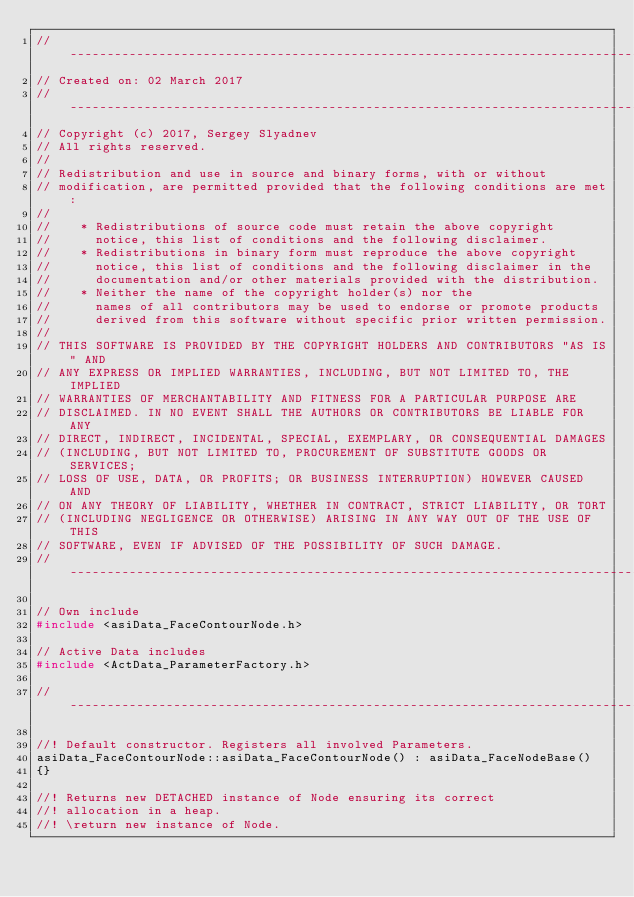Convert code to text. <code><loc_0><loc_0><loc_500><loc_500><_C++_>//-----------------------------------------------------------------------------
// Created on: 02 March 2017
//-----------------------------------------------------------------------------
// Copyright (c) 2017, Sergey Slyadnev
// All rights reserved.
//
// Redistribution and use in source and binary forms, with or without
// modification, are permitted provided that the following conditions are met:
//
//    * Redistributions of source code must retain the above copyright
//      notice, this list of conditions and the following disclaimer.
//    * Redistributions in binary form must reproduce the above copyright
//      notice, this list of conditions and the following disclaimer in the
//      documentation and/or other materials provided with the distribution.
//    * Neither the name of the copyright holder(s) nor the
//      names of all contributors may be used to endorse or promote products
//      derived from this software without specific prior written permission.
//
// THIS SOFTWARE IS PROVIDED BY THE COPYRIGHT HOLDERS AND CONTRIBUTORS "AS IS" AND
// ANY EXPRESS OR IMPLIED WARRANTIES, INCLUDING, BUT NOT LIMITED TO, THE IMPLIED
// WARRANTIES OF MERCHANTABILITY AND FITNESS FOR A PARTICULAR PURPOSE ARE
// DISCLAIMED. IN NO EVENT SHALL THE AUTHORS OR CONTRIBUTORS BE LIABLE FOR ANY
// DIRECT, INDIRECT, INCIDENTAL, SPECIAL, EXEMPLARY, OR CONSEQUENTIAL DAMAGES
// (INCLUDING, BUT NOT LIMITED TO, PROCUREMENT OF SUBSTITUTE GOODS OR SERVICES;
// LOSS OF USE, DATA, OR PROFITS; OR BUSINESS INTERRUPTION) HOWEVER CAUSED AND
// ON ANY THEORY OF LIABILITY, WHETHER IN CONTRACT, STRICT LIABILITY, OR TORT
// (INCLUDING NEGLIGENCE OR OTHERWISE) ARISING IN ANY WAY OUT OF THE USE OF THIS
// SOFTWARE, EVEN IF ADVISED OF THE POSSIBILITY OF SUCH DAMAGE.
//-----------------------------------------------------------------------------

// Own include
#include <asiData_FaceContourNode.h>

// Active Data includes
#include <ActData_ParameterFactory.h>

//-----------------------------------------------------------------------------

//! Default constructor. Registers all involved Parameters.
asiData_FaceContourNode::asiData_FaceContourNode() : asiData_FaceNodeBase()
{}

//! Returns new DETACHED instance of Node ensuring its correct
//! allocation in a heap.
//! \return new instance of Node.</code> 